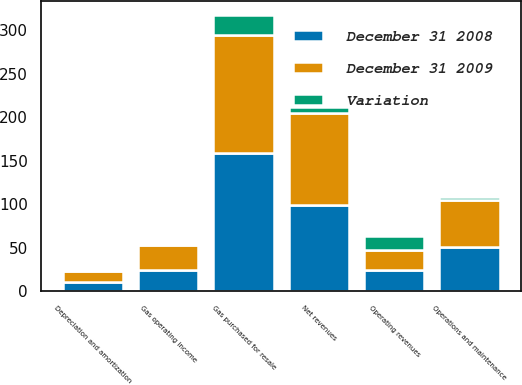<chart> <loc_0><loc_0><loc_500><loc_500><stacked_bar_chart><ecel><fcel>Operating revenues<fcel>Gas purchased for resale<fcel>Net revenues<fcel>Operations and maintenance<fcel>Depreciation and amortization<fcel>Gas operating income<nl><fcel>December 31 2009<fcel>24<fcel>136<fcel>106<fcel>54<fcel>12<fcel>28<nl><fcel>December 31 2008<fcel>24<fcel>159<fcel>99<fcel>51<fcel>11<fcel>25<nl><fcel>Variation<fcel>16<fcel>23<fcel>7<fcel>3<fcel>1<fcel>3<nl></chart> 